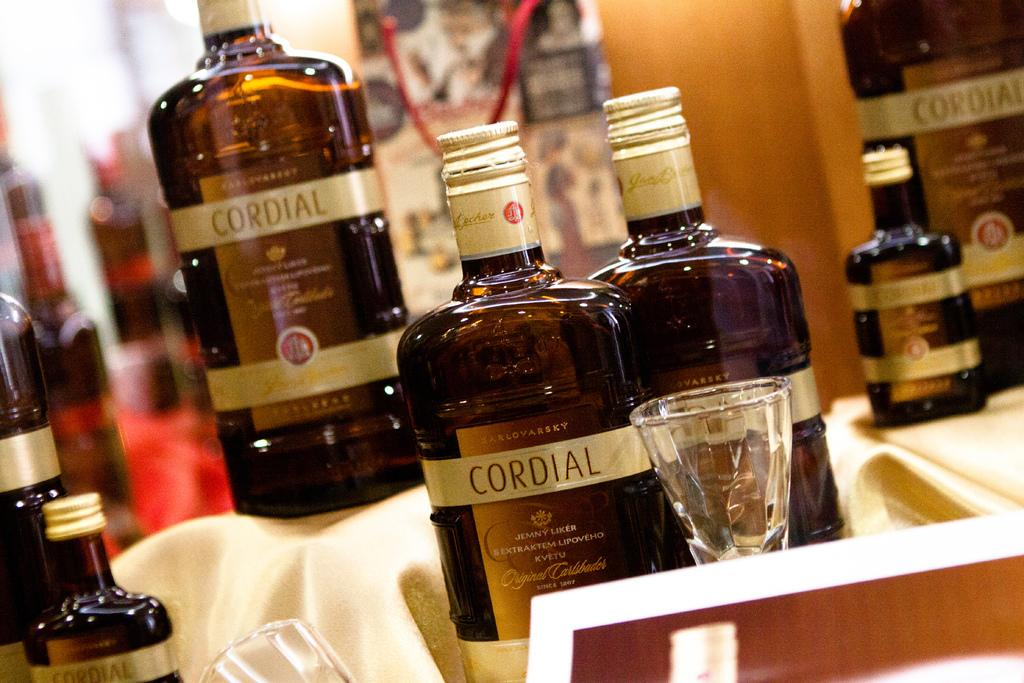<image>
Provide a brief description of the given image. Several bottles of Cordial sit on a table together. 